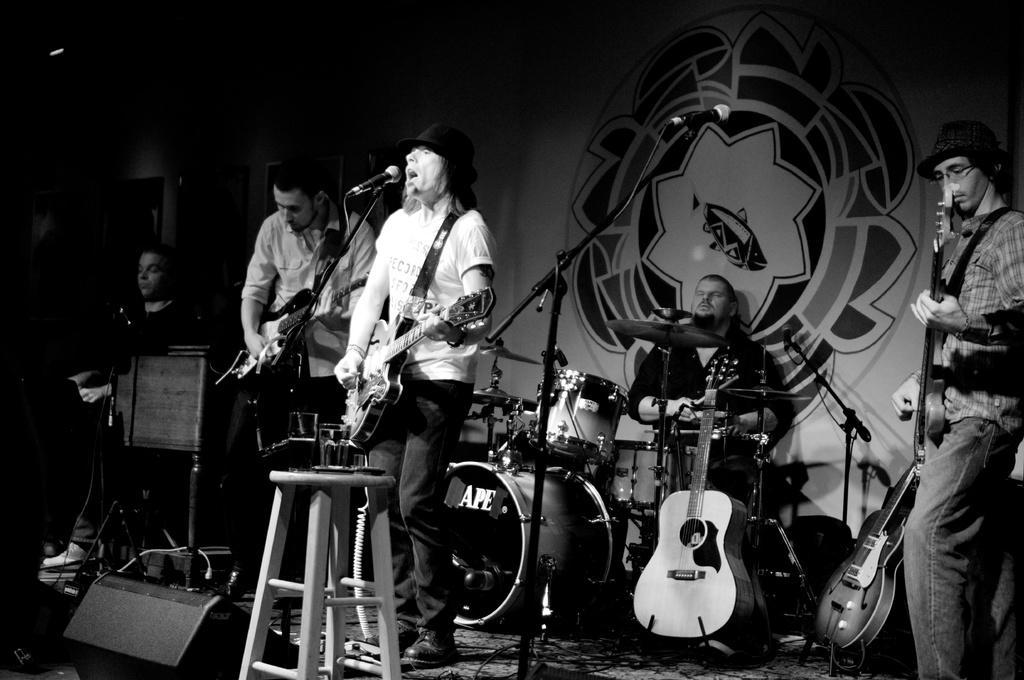Can you describe this image briefly? There are many persons. One person holding guitar and playing and singing. Another person is holding guitar and playing. In the right corner a person wearing cap is holding guitar and playing. In the background there is a person wearing drums. There are some guitars on the floor. There is a stool. On the stool there is a glass. There are speakers. In the background there is a banner. There is a mic, mic stand. 